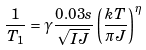<formula> <loc_0><loc_0><loc_500><loc_500>\frac { 1 } { T _ { 1 } } = \gamma \frac { 0 . 0 3 s } { \sqrt { I J } } \left ( \frac { k T } { \pi J } \right ) ^ { \eta }</formula> 